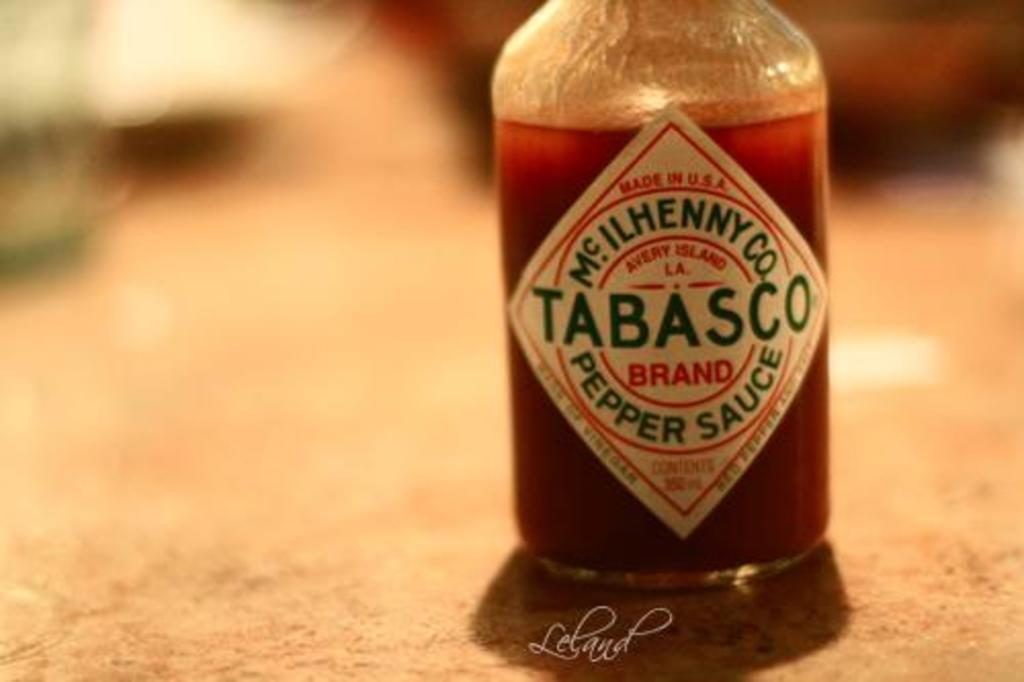What can be seen at the bottom of the image? There is a watermark at the bottom of the image. What is located on the right side of the image? There is a bottle filled with a drink on the right side of the image. What is on the bottle? The bottle has a sticker on it. How would you describe the background of the image? The background of the image is blurred. Can you see any hills in the background of the image? There are no hills visible in the image; the background is blurred. Is there a prison depicted in the image? There is no prison present in the image. 